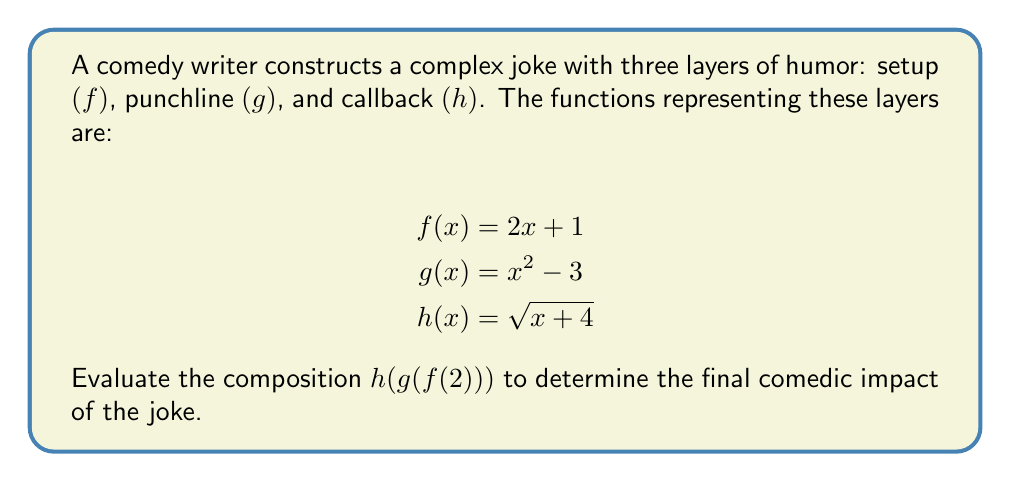Could you help me with this problem? To evaluate the composition $h(g(f(2)))$, we need to work from the innermost function outward:

1. Evaluate $f(2)$:
   $f(2) = 2(2) + 1 = 4 + 1 = 5$

2. Now evaluate $g(f(2))$, which is equivalent to $g(5)$:
   $g(5) = 5^2 - 3 = 25 - 3 = 22$

3. Finally, evaluate $h(g(f(2)))$, which is now $h(22)$:
   $h(22) = \sqrt{22 + 4} = \sqrt{26}$

Therefore, the final comedic impact of the joke is represented by $\sqrt{26}$.
Answer: $\sqrt{26}$ 